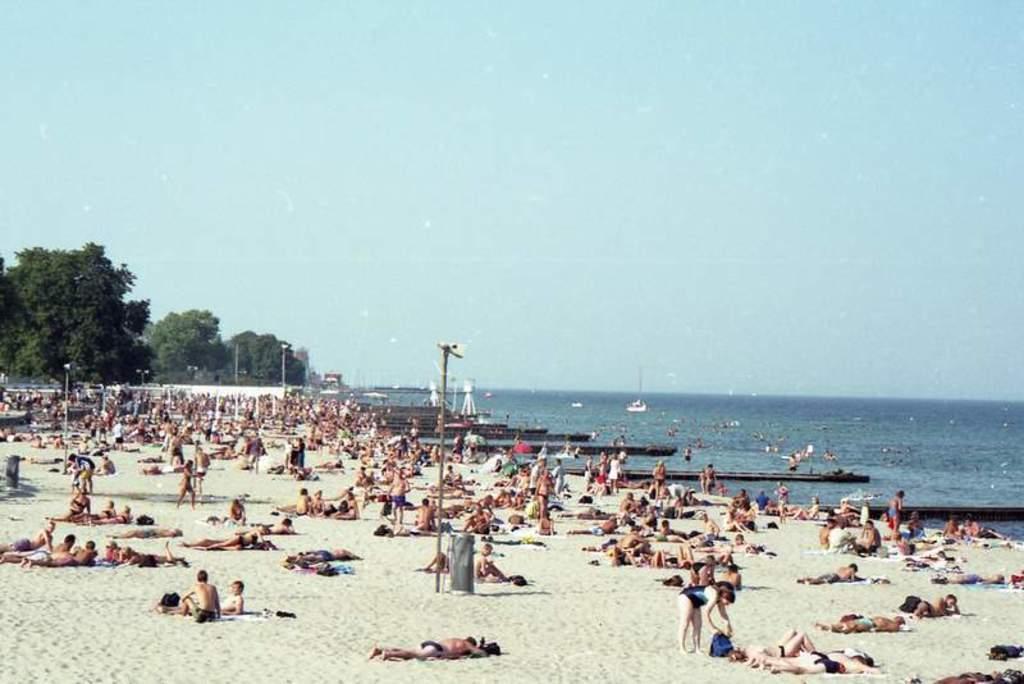How would you summarize this image in a sentence or two? Here we can see people,sand and pole. In the background we can see water,trees and sky. 